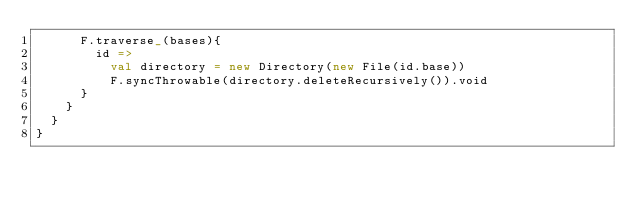<code> <loc_0><loc_0><loc_500><loc_500><_Scala_>      F.traverse_(bases){
        id =>
          val directory = new Directory(new File(id.base))
          F.syncThrowable(directory.deleteRecursively()).void
      }
    }
  }
}
</code> 